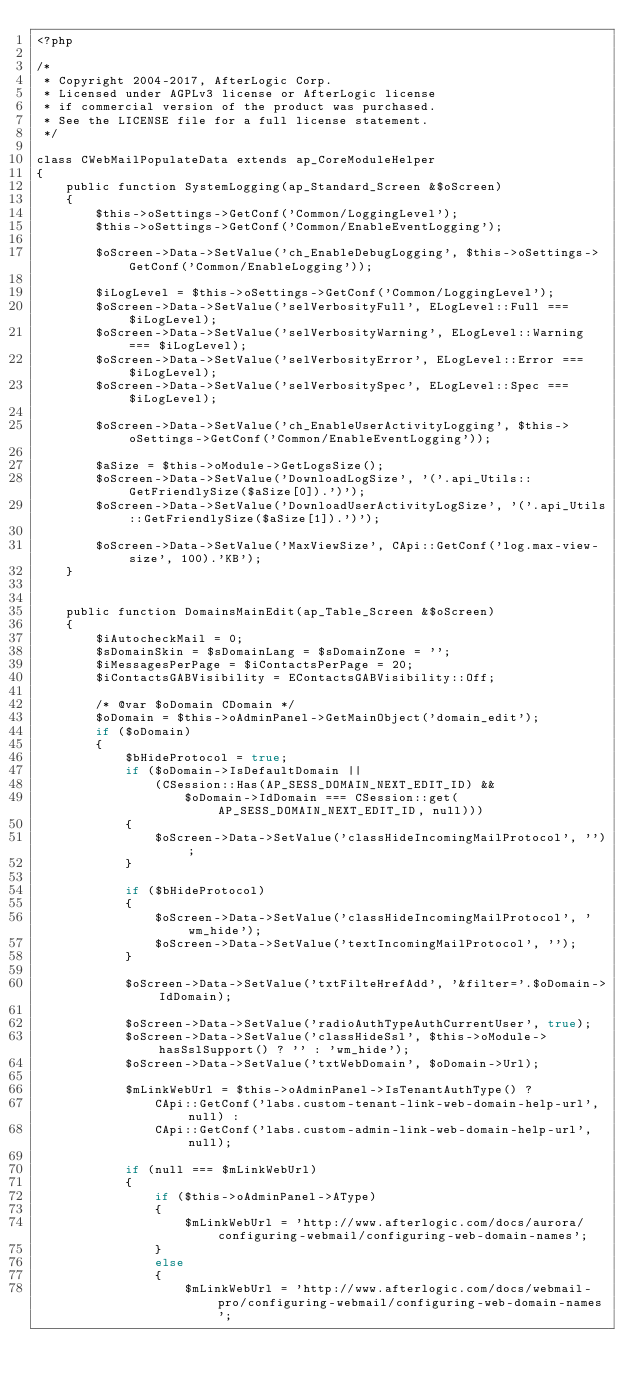<code> <loc_0><loc_0><loc_500><loc_500><_PHP_><?php

/*
 * Copyright 2004-2017, AfterLogic Corp.
 * Licensed under AGPLv3 license or AfterLogic license
 * if commercial version of the product was purchased.
 * See the LICENSE file for a full license statement.
 */

class CWebMailPopulateData extends ap_CoreModuleHelper
{
	public function SystemLogging(ap_Standard_Screen &$oScreen)
	{
		$this->oSettings->GetConf('Common/LoggingLevel');
		$this->oSettings->GetConf('Common/EnableEventLogging');

		$oScreen->Data->SetValue('ch_EnableDebugLogging', $this->oSettings->GetConf('Common/EnableLogging'));

		$iLogLevel = $this->oSettings->GetConf('Common/LoggingLevel');
		$oScreen->Data->SetValue('selVerbosityFull', ELogLevel::Full === $iLogLevel);
		$oScreen->Data->SetValue('selVerbosityWarning', ELogLevel::Warning === $iLogLevel);
		$oScreen->Data->SetValue('selVerbosityError', ELogLevel::Error === $iLogLevel);
		$oScreen->Data->SetValue('selVerbositySpec', ELogLevel::Spec === $iLogLevel);

		$oScreen->Data->SetValue('ch_EnableUserActivityLogging', $this->oSettings->GetConf('Common/EnableEventLogging'));

		$aSize = $this->oModule->GetLogsSize();
		$oScreen->Data->SetValue('DownloadLogSize', '('.api_Utils::GetFriendlySize($aSize[0]).')');
		$oScreen->Data->SetValue('DownloadUserActivityLogSize', '('.api_Utils::GetFriendlySize($aSize[1]).')');

		$oScreen->Data->SetValue('MaxViewSize', CApi::GetConf('log.max-view-size', 100).'KB');
	}


	public function DomainsMainEdit(ap_Table_Screen &$oScreen)
	{
		$iAutocheckMail = 0;
		$sDomainSkin = $sDomainLang = $sDomainZone = '';
		$iMessagesPerPage = $iContactsPerPage = 20;
		$iContactsGABVisibility = EContactsGABVisibility::Off;

		/* @var $oDomain CDomain */
		$oDomain = $this->oAdminPanel->GetMainObject('domain_edit');
		if ($oDomain)
		{
			$bHideProtocol = true;
			if ($oDomain->IsDefaultDomain ||
				(CSession::Has(AP_SESS_DOMAIN_NEXT_EDIT_ID) &&
					$oDomain->IdDomain === CSession::get(AP_SESS_DOMAIN_NEXT_EDIT_ID, null)))
			{
				$oScreen->Data->SetValue('classHideIncomingMailProtocol', '');
			}

			if ($bHideProtocol)
			{
				$oScreen->Data->SetValue('classHideIncomingMailProtocol', 'wm_hide');
				$oScreen->Data->SetValue('textIncomingMailProtocol', '');
			}

			$oScreen->Data->SetValue('txtFilteHrefAdd', '&filter='.$oDomain->IdDomain);

			$oScreen->Data->SetValue('radioAuthTypeAuthCurrentUser', true);
			$oScreen->Data->SetValue('classHideSsl', $this->oModule->hasSslSupport() ? '' : 'wm_hide');
			$oScreen->Data->SetValue('txtWebDomain', $oDomain->Url);

			$mLinkWebUrl = $this->oAdminPanel->IsTenantAuthType() ?
				CApi::GetConf('labs.custom-tenant-link-web-domain-help-url', null) :
				CApi::GetConf('labs.custom-admin-link-web-domain-help-url', null);

			if (null === $mLinkWebUrl)
			{
				if ($this->oAdminPanel->AType)
				{
					$mLinkWebUrl = 'http://www.afterlogic.com/docs/aurora/configuring-webmail/configuring-web-domain-names';
				}
				else
				{
					$mLinkWebUrl = 'http://www.afterlogic.com/docs/webmail-pro/configuring-webmail/configuring-web-domain-names';</code> 